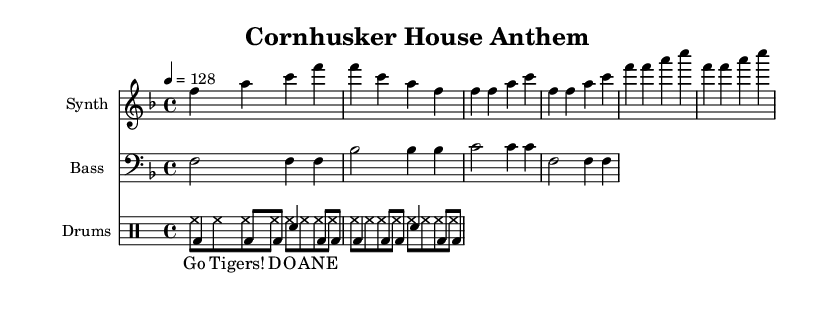What is the key signature of this music? The key signature is F major, indicated by one flat (B flat). This can be deduced from the key signature notation at the beginning of the sheet music.
Answer: F major What is the time signature of this music? The time signature is 4/4, also found at the beginning of the sheet music. This means there are four beats in each measure and the quarter note receives one beat.
Answer: 4/4 What is the tempo marking in this piece? The tempo marking indicates a speed of 128 beats per minute, clearly stated in the tempo section of the music sheet.
Answer: 128 Identify the type of drum pattern presented in the sheet music. The drum pattern consists of a bass drum and snare drum, evidenced by the use of the notation bd for bass drum and sn for snare drum in the drumsPitched section. This is typical of electronic and energetic House music, often used to build up rhythm during the piece.
Answer: Bass and snare How many measures are there in the synthesizer part? The synthesizer part consists of 8 measures, shown by counting the groups of notes and the measure lines in the synthesizer section of the music.
Answer: 8 What chant is included in the lyrics? The chant included is "Go Tigers! D O A N E," which is noted in the lyrics section and is typical for energizing crowds during football games, aligning well with the energetic House music theme.
Answer: Go Tigers! D O A N E What genre does this music represent? The music represents the House genre, which is evident from the energetic beat patterns, use of synthesizers, and incorporation of crowd chants commonly associated with House music.
Answer: House 